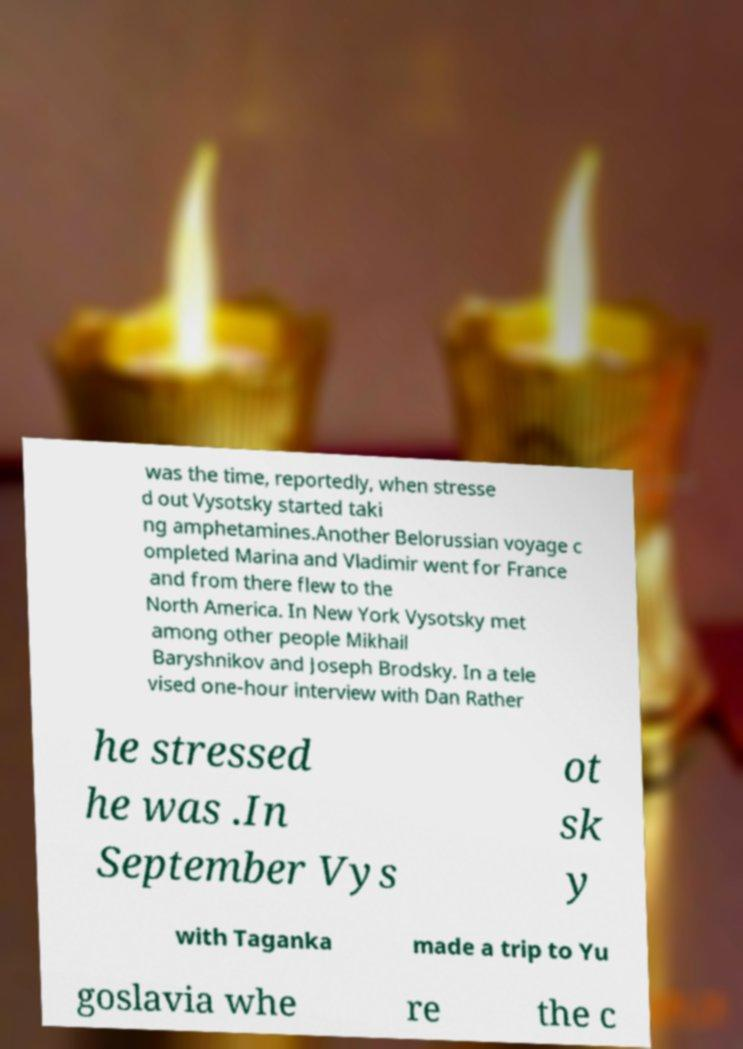Could you assist in decoding the text presented in this image and type it out clearly? was the time, reportedly, when stresse d out Vysotsky started taki ng amphetamines.Another Belorussian voyage c ompleted Marina and Vladimir went for France and from there flew to the North America. In New York Vysotsky met among other people Mikhail Baryshnikov and Joseph Brodsky. In a tele vised one-hour interview with Dan Rather he stressed he was .In September Vys ot sk y with Taganka made a trip to Yu goslavia whe re the c 